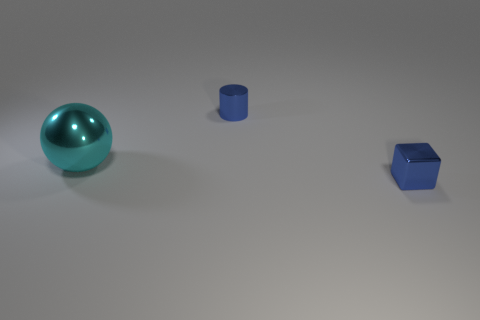Add 3 large cyan metallic things. How many objects exist? 6 Subtract all cylinders. How many objects are left? 2 Subtract all large spheres. Subtract all tiny gray blocks. How many objects are left? 2 Add 1 small shiny cubes. How many small shiny cubes are left? 2 Add 2 small cyan spheres. How many small cyan spheres exist? 2 Subtract 1 blue cubes. How many objects are left? 2 